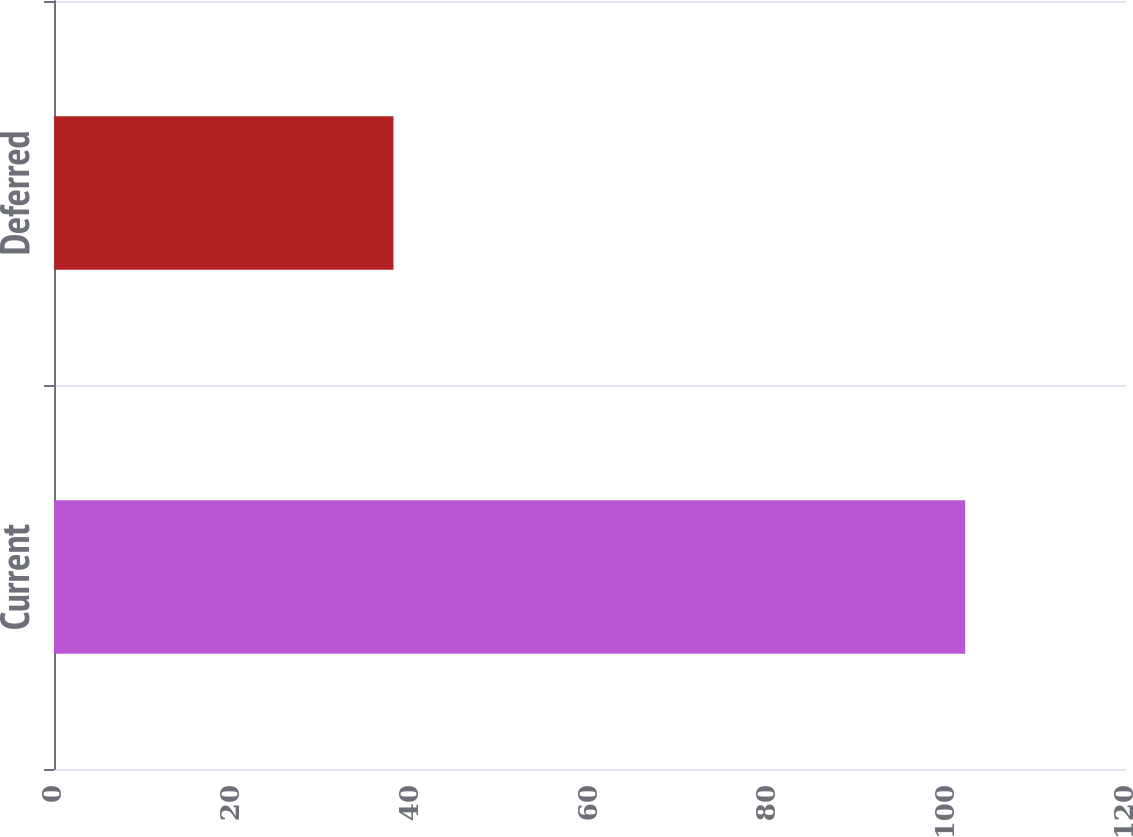<chart> <loc_0><loc_0><loc_500><loc_500><bar_chart><fcel>Current<fcel>Deferred<nl><fcel>102<fcel>38<nl></chart> 